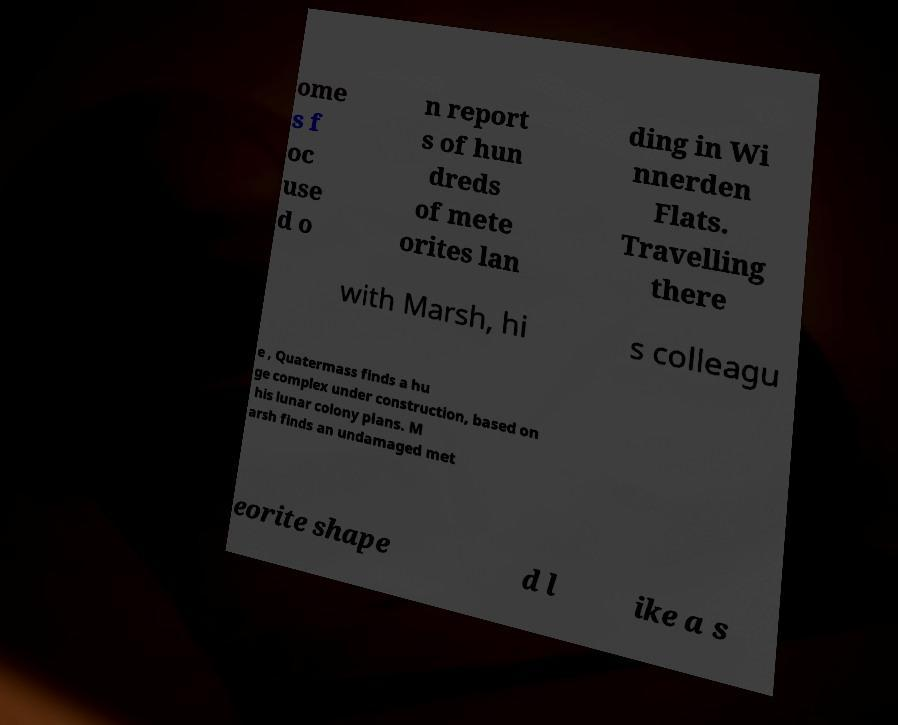Please read and relay the text visible in this image. What does it say? ome s f oc use d o n report s of hun dreds of mete orites lan ding in Wi nnerden Flats. Travelling there with Marsh, hi s colleagu e , Quatermass finds a hu ge complex under construction, based on his lunar colony plans. M arsh finds an undamaged met eorite shape d l ike a s 